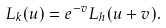<formula> <loc_0><loc_0><loc_500><loc_500>L _ { k } ( u ) = e ^ { - v } L _ { h } ( u + v ) .</formula> 